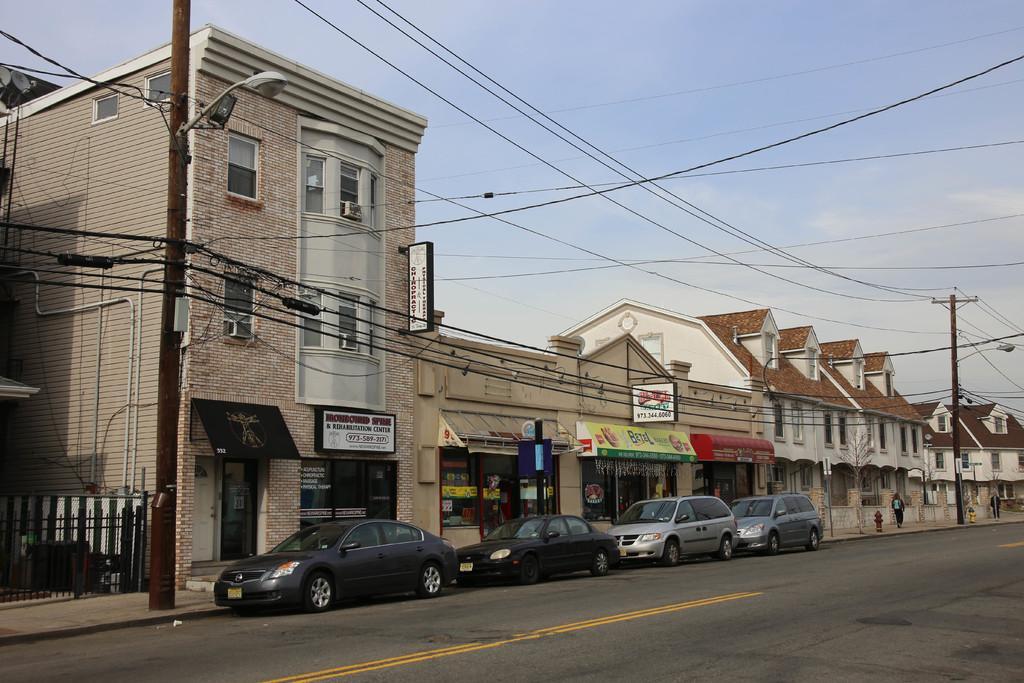Please provide a concise description of this image. There are four cars on the road. Here we can see poles, wires, boards, fence, buildings, hydrant, and two persons. In the background there is sky. 